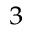Convert formula to latex. <formula><loc_0><loc_0><loc_500><loc_500>_ { 3 }</formula> 